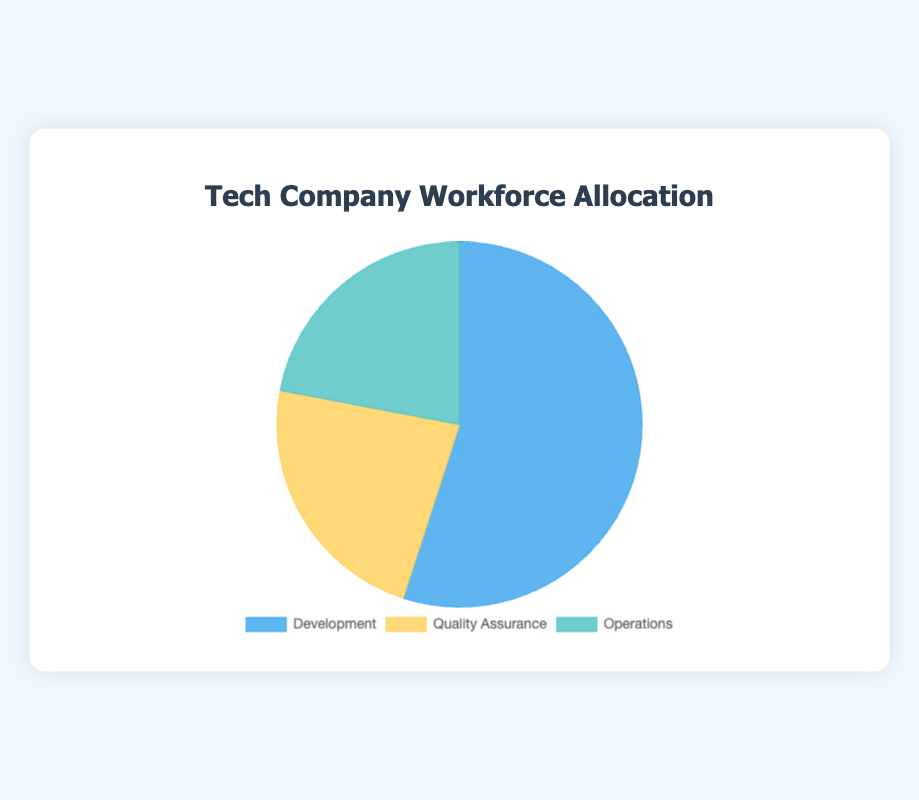What department has the largest headcount? The Development department has the highest headcount at 120, as represented by the largest section of the pie chart.
Answer: Development Which department has the smallest percentage of the workforce? The Operations department has the smallest percentage of the workforce at 22%, as reflected by the smallest segment in the pie chart.
Answer: Operations What's the difference in headcount between the Development and Quality Assurance departments? The headcount for Development is 120 and for Quality Assurance is 50. The difference is 120 - 50 = 70.
Answer: 70 How do the headcounts of Quality Assurance and Operations compare? The headcount for Quality Assurance is 50, while the headcount for Operations is 48. Thus, Quality Assurance has 2 more people than Operations.
Answer: Quality Assurance has 2 more people What percentage of the workforce is allocated to Quality Assurance and Operations combined? The percentage for Quality Assurance is 23% and for Operations is 22%. Combined, they are 23% + 22% = 45%.
Answer: 45% Which department has a nearly equal headcount compared to another? The Operations department has 48 people, and the Quality Assurance department has 50 people, making them nearly equal in headcount.
Answer: Operations and Quality Assurance What fraction of the total workforce does the Development department represent? The Development department represents 55% of the total workforce, which simplifies to 55/100 or approximately 11/20 of the total workforce.
Answer: 11/20 If the total workforce is expanded to 250 employees while maintaining the same distribution, what would be the new headcount for the Operations department? The current Operations headcount is 22% of the total workforce. With a new total of 250 employees, 22% of 250 = 0.22 * 250 = 55.
Answer: 55 What's the combined headcount of Development and Operations? The headcount for Development is 120 and for Operations is 48. The combined headcount is 120 + 48 = 168.
Answer: 168 When considering color for departments, what color represents the Quality Assurance department? The Quality Assurance department is represented by the yellow section of the pie chart.
Answer: Yellow 